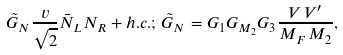<formula> <loc_0><loc_0><loc_500><loc_500>\tilde { G } _ { N } \frac { v } { \sqrt { 2 } } \bar { N } _ { L } N _ { R } + h . c . ; \, \tilde { G } _ { N } = G _ { 1 } G _ { M _ { 2 } } G _ { 3 } \frac { V \, V ^ { \prime } } { M _ { F } \, M _ { 2 } } ,</formula> 